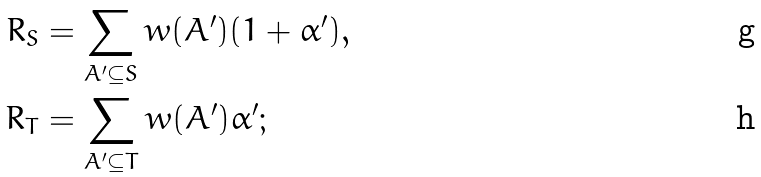<formula> <loc_0><loc_0><loc_500><loc_500>R _ { S } & = \sum _ { A ^ { \prime } \subseteq S } w ( A ^ { \prime } ) ( 1 + \alpha ^ { \prime } ) , \\ R _ { T } & = \sum _ { A ^ { \prime } \subseteq T } w ( A ^ { \prime } ) \alpha ^ { \prime } ;</formula> 